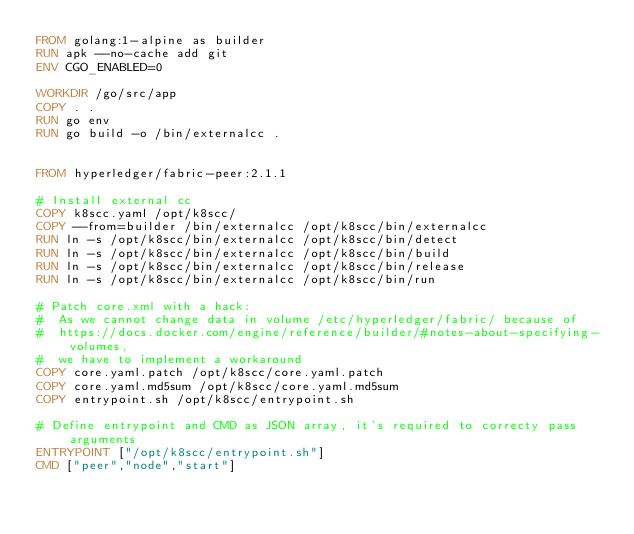<code> <loc_0><loc_0><loc_500><loc_500><_Dockerfile_>FROM golang:1-alpine as builder
RUN apk --no-cache add git
ENV CGO_ENABLED=0

WORKDIR /go/src/app
COPY . .
RUN go env
RUN go build -o /bin/externalcc .


FROM hyperledger/fabric-peer:2.1.1

# Install external cc
COPY k8scc.yaml /opt/k8scc/
COPY --from=builder /bin/externalcc /opt/k8scc/bin/externalcc
RUN ln -s /opt/k8scc/bin/externalcc /opt/k8scc/bin/detect
RUN ln -s /opt/k8scc/bin/externalcc /opt/k8scc/bin/build
RUN ln -s /opt/k8scc/bin/externalcc /opt/k8scc/bin/release
RUN ln -s /opt/k8scc/bin/externalcc /opt/k8scc/bin/run

# Patch core.xml with a hack:
#  As we cannot change data in volume /etc/hyperledger/fabric/ because of
#  https://docs.docker.com/engine/reference/builder/#notes-about-specifying-volumes,
#  we have to implement a workaround
COPY core.yaml.patch /opt/k8scc/core.yaml.patch
COPY core.yaml.md5sum /opt/k8scc/core.yaml.md5sum
COPY entrypoint.sh /opt/k8scc/entrypoint.sh

# Define entrypoint and CMD as JSON array, it's required to correcty pass arguments
ENTRYPOINT ["/opt/k8scc/entrypoint.sh"]
CMD ["peer","node","start"]
</code> 